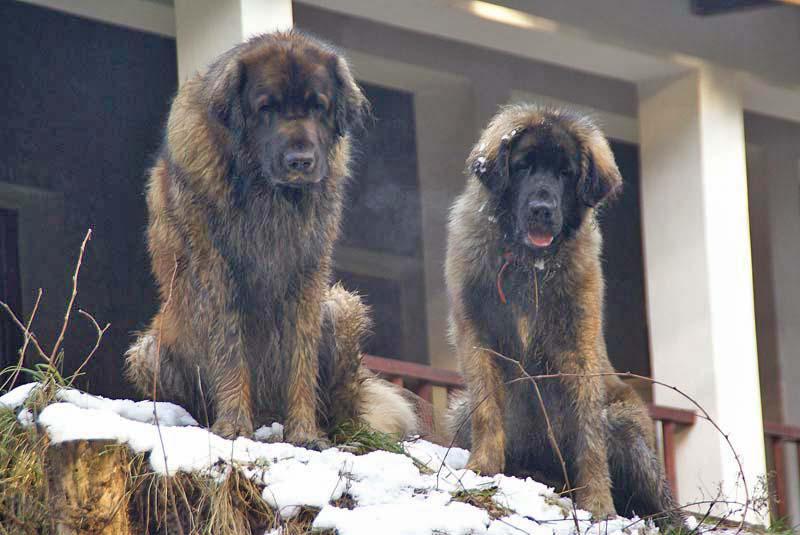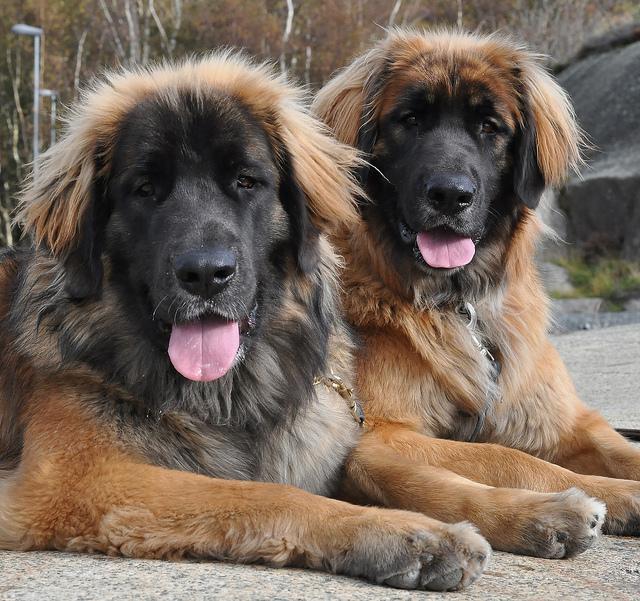The first image is the image on the left, the second image is the image on the right. Examine the images to the left and right. Is the description "In one image, two dogs of the same breed are near a fence, while the other image shows a single dog with its mouth open and tongue visible." accurate? Answer yes or no. No. 